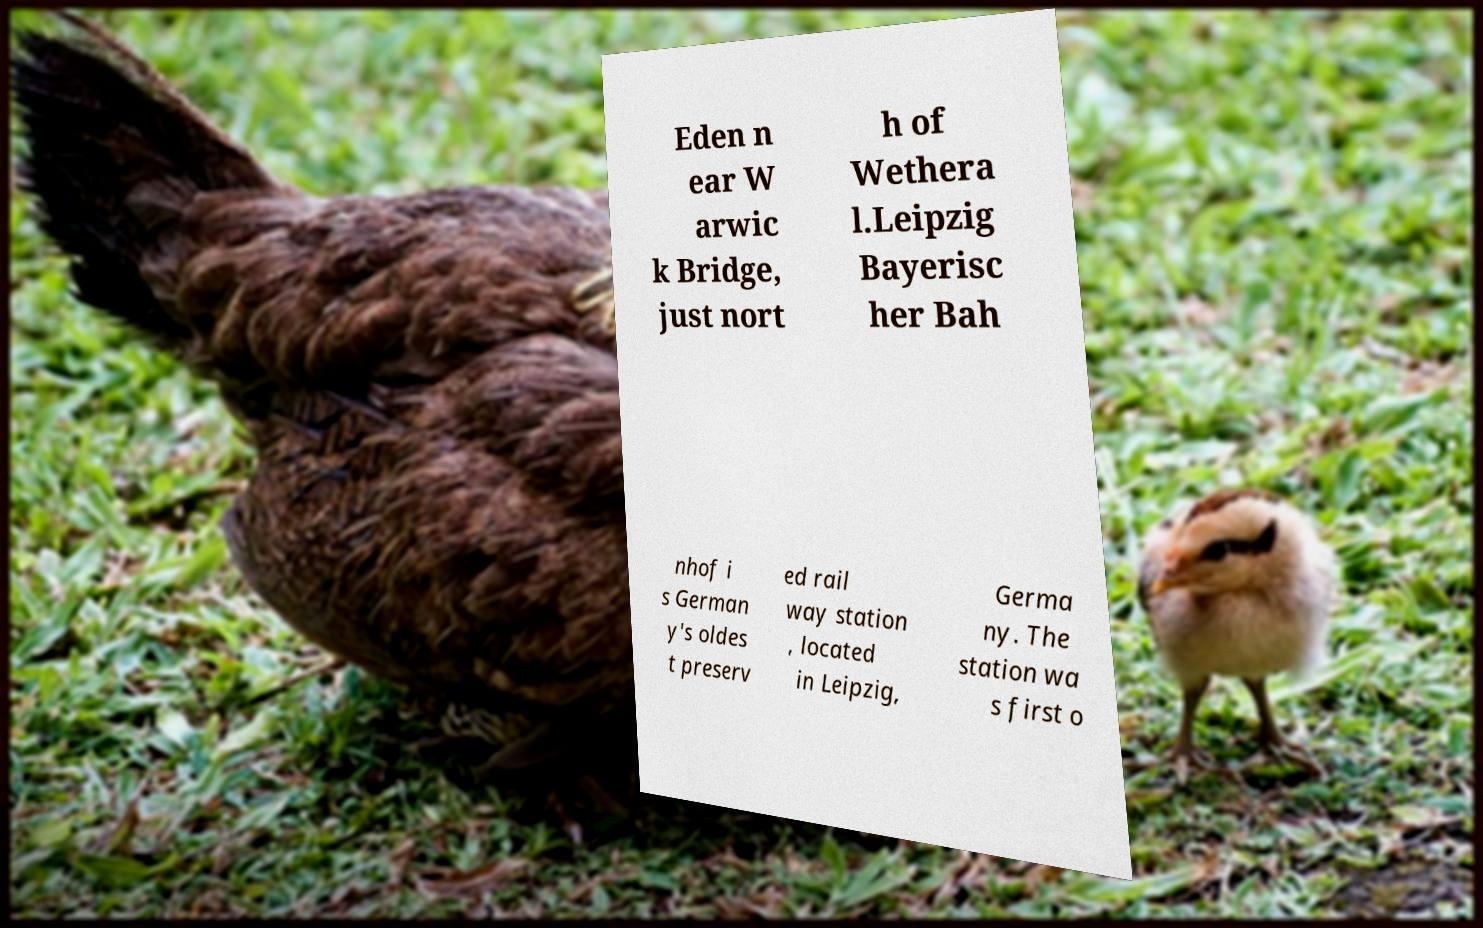For documentation purposes, I need the text within this image transcribed. Could you provide that? Eden n ear W arwic k Bridge, just nort h of Wethera l.Leipzig Bayerisc her Bah nhof i s German y's oldes t preserv ed rail way station , located in Leipzig, Germa ny. The station wa s first o 